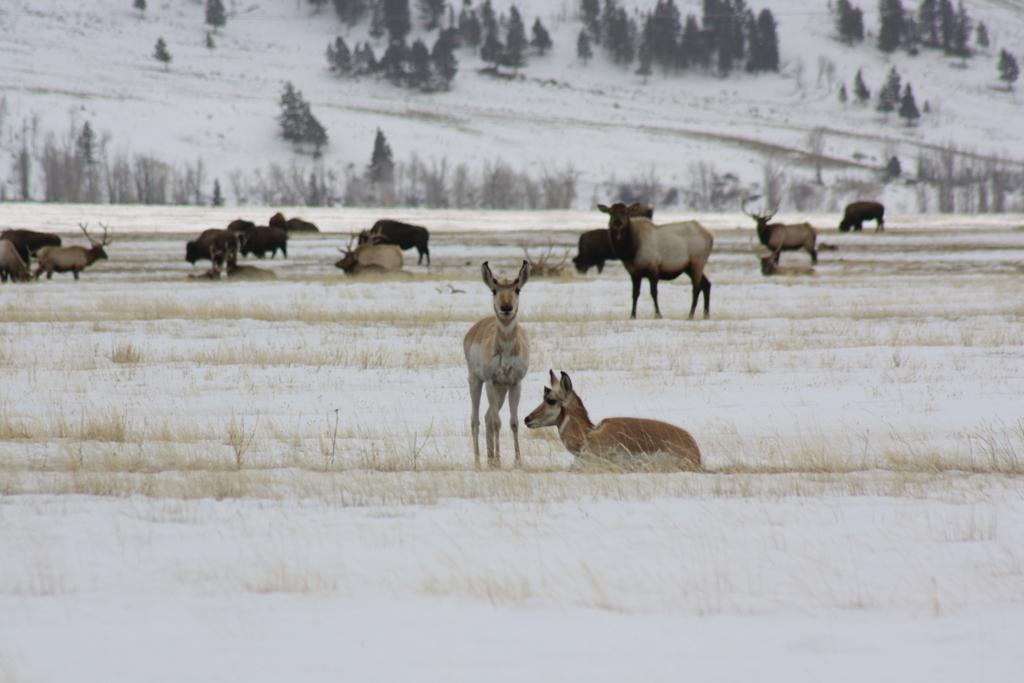What is the main subject of the image? There is a group of animals in the image. What is the setting of the image? The animals are in the snow. What can be seen in the background of the image? There are plants visible in the background of the image. What type of vegetation is present at the top of the image? There is a group of trees at the top of the image. What type of adjustment can be seen on the goat's horns in the image? There is no goat present in the image, and therefore no adjustment can be observed on its horns. 